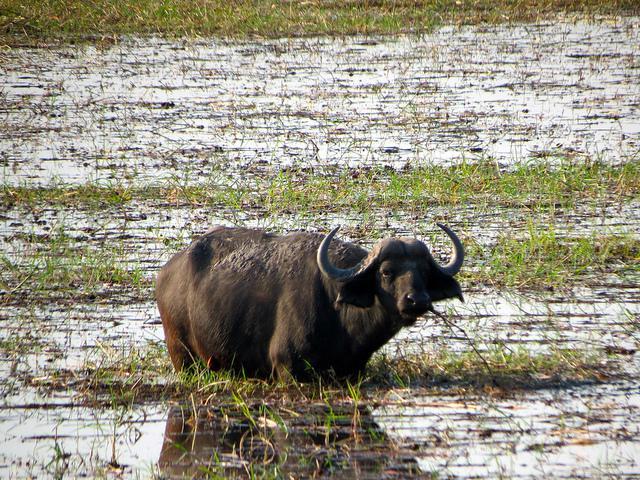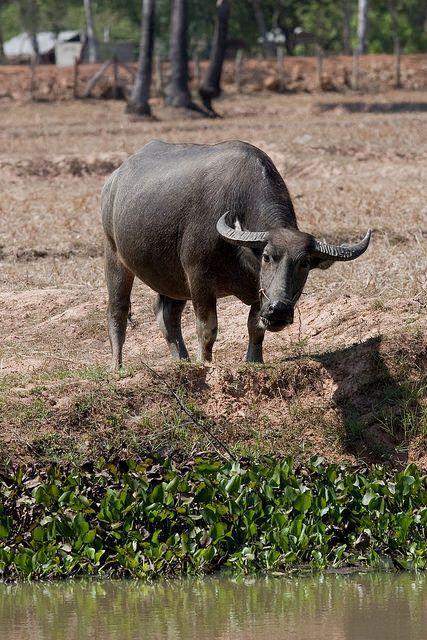The first image is the image on the left, the second image is the image on the right. For the images shown, is this caption "An image shows an ox-type animal in the mud." true? Answer yes or no. No. 